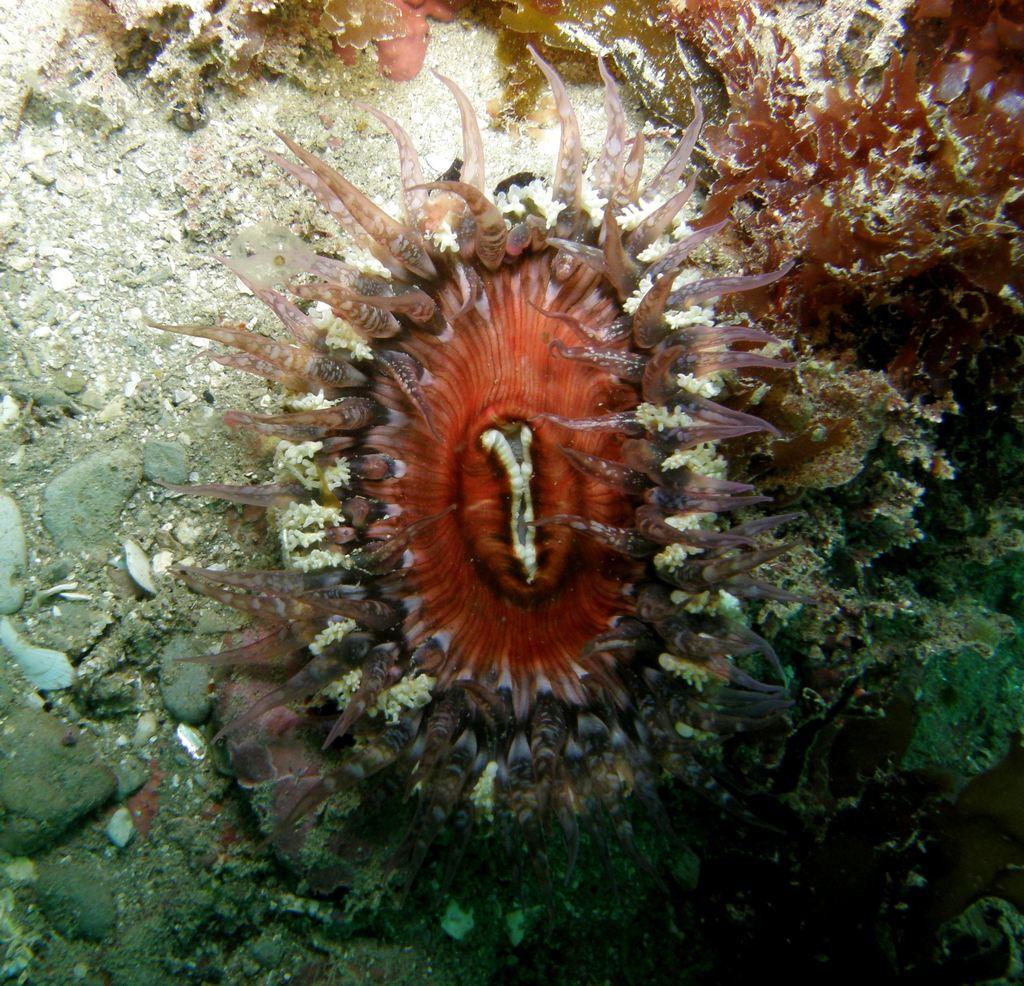What is the main subject in the middle of the image? There is a plant in the middle of the image. What else can be seen in the image besides the plant? There are many rocks in the image. What type of body part is visible in the image? There is no body part visible in the image; it features a plant and rocks. What type of picture is being displayed in the image? The image itself is not a picture of another image, but rather a photograph of a plant and rocks. 